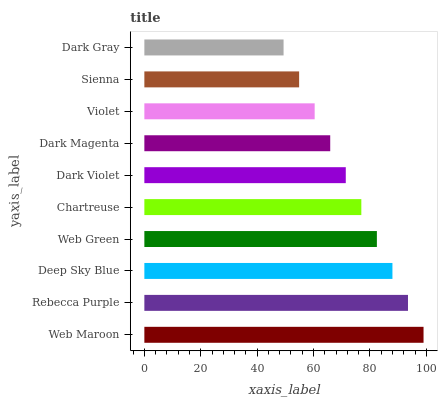Is Dark Gray the minimum?
Answer yes or no. Yes. Is Web Maroon the maximum?
Answer yes or no. Yes. Is Rebecca Purple the minimum?
Answer yes or no. No. Is Rebecca Purple the maximum?
Answer yes or no. No. Is Web Maroon greater than Rebecca Purple?
Answer yes or no. Yes. Is Rebecca Purple less than Web Maroon?
Answer yes or no. Yes. Is Rebecca Purple greater than Web Maroon?
Answer yes or no. No. Is Web Maroon less than Rebecca Purple?
Answer yes or no. No. Is Chartreuse the high median?
Answer yes or no. Yes. Is Dark Violet the low median?
Answer yes or no. Yes. Is Sienna the high median?
Answer yes or no. No. Is Dark Magenta the low median?
Answer yes or no. No. 